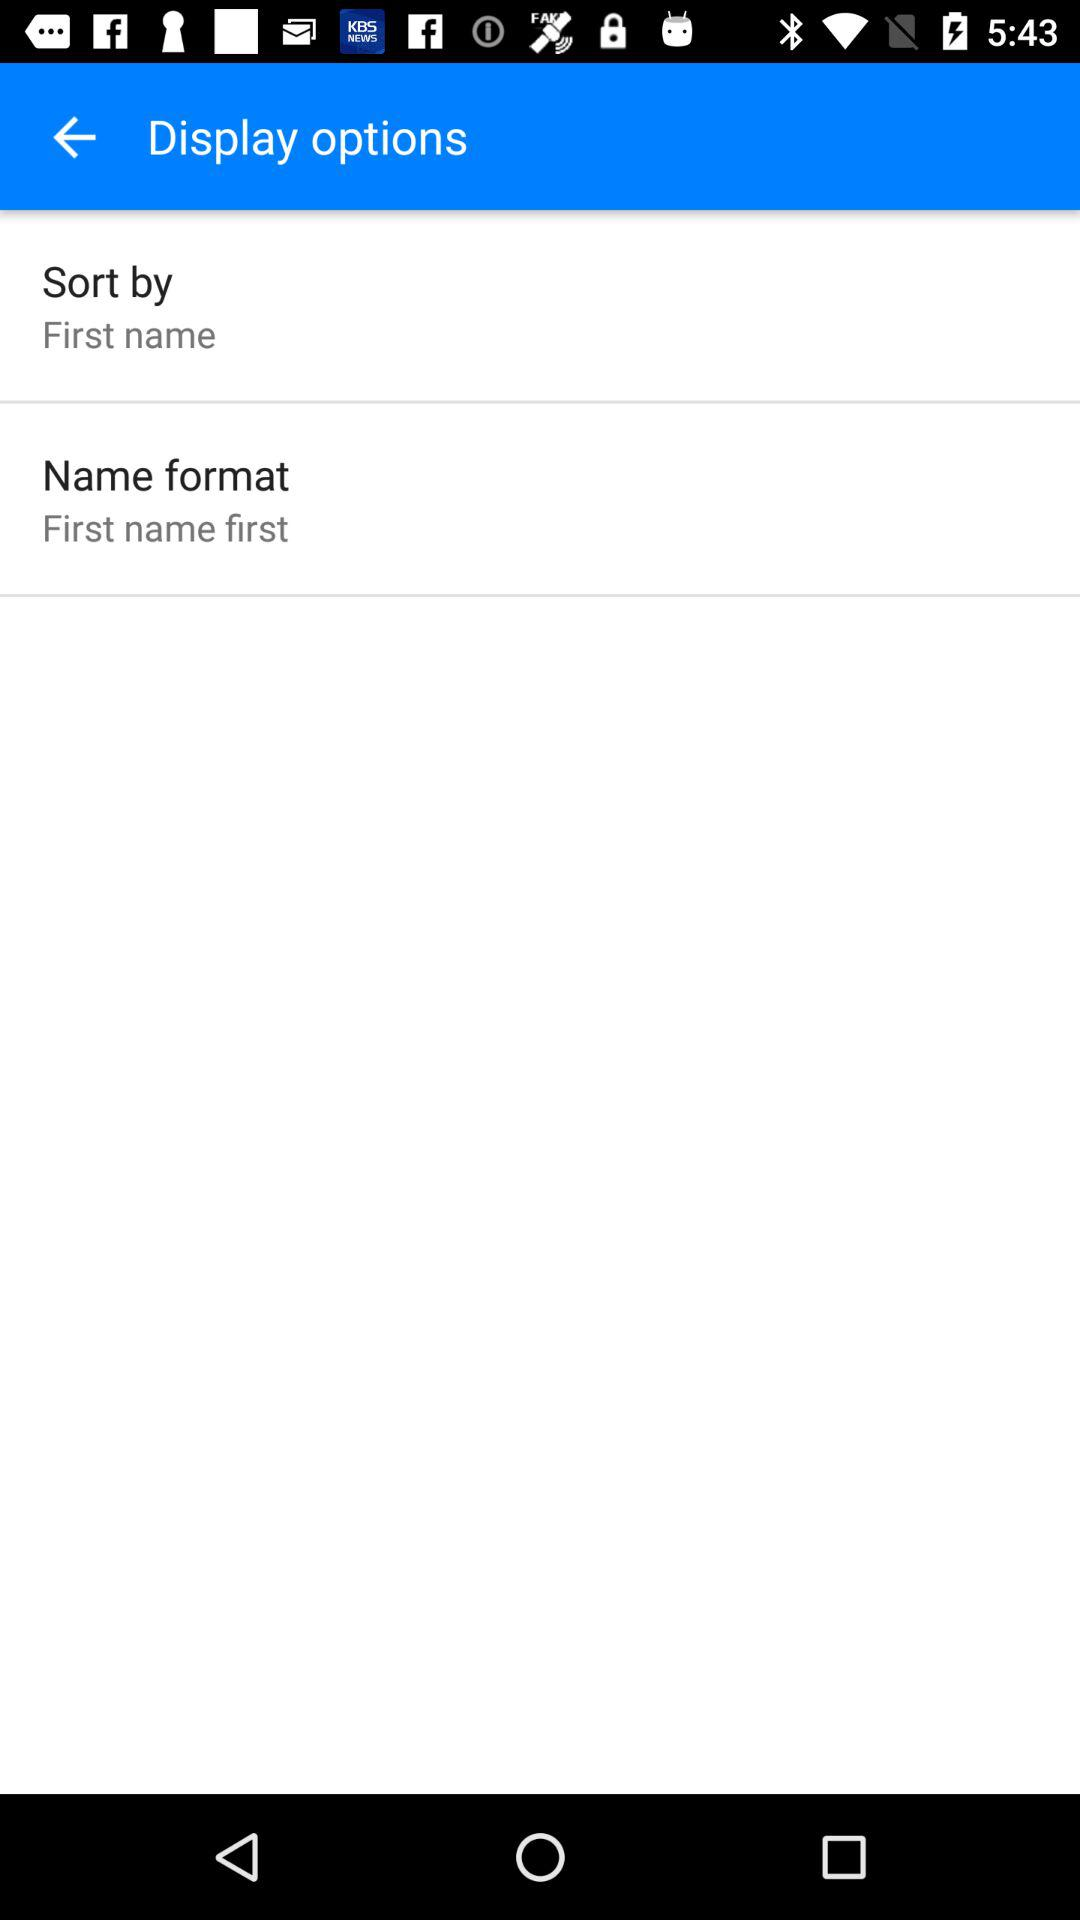What is the name format? The name format is "First name first". 